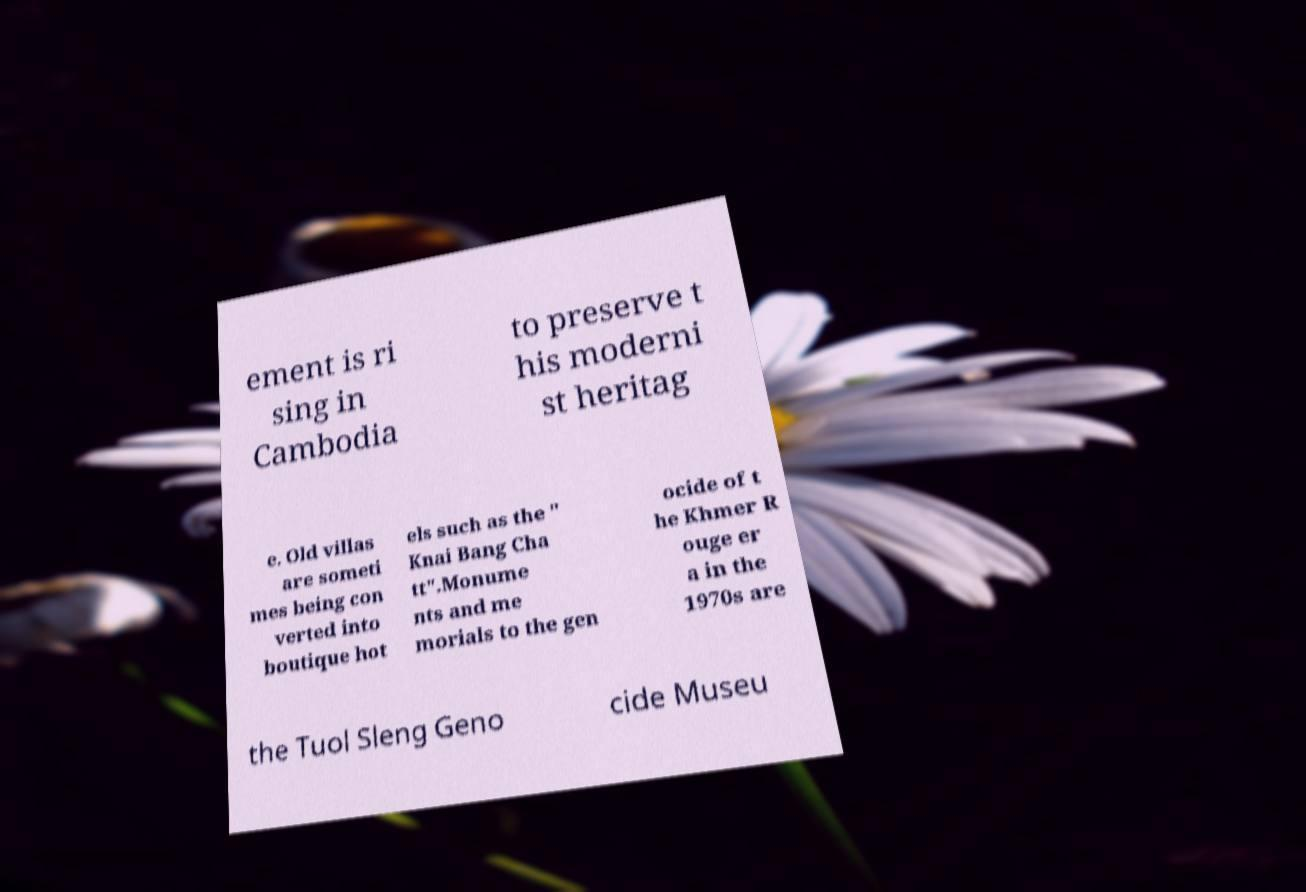Could you assist in decoding the text presented in this image and type it out clearly? ement is ri sing in Cambodia to preserve t his moderni st heritag e. Old villas are someti mes being con verted into boutique hot els such as the " Knai Bang Cha tt".Monume nts and me morials to the gen ocide of t he Khmer R ouge er a in the 1970s are the Tuol Sleng Geno cide Museu 